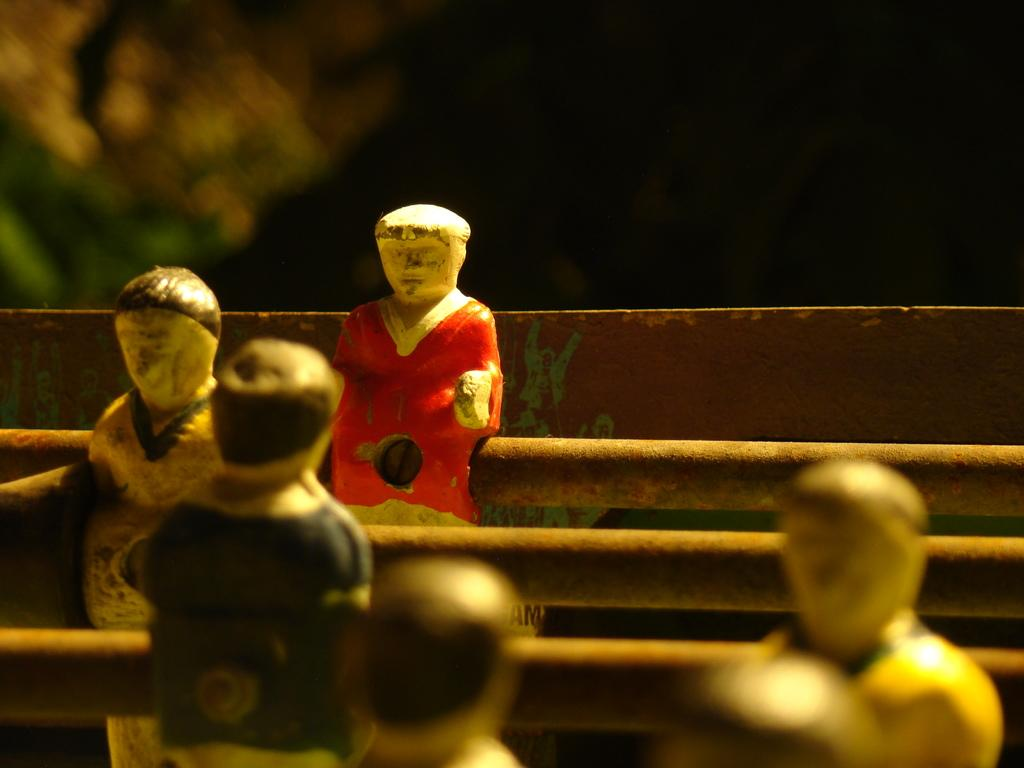What type of objects can be seen in the image? There are toys in the image. What type of cast can be seen on the toys in the image? There is no cast present on the toys in the image. 